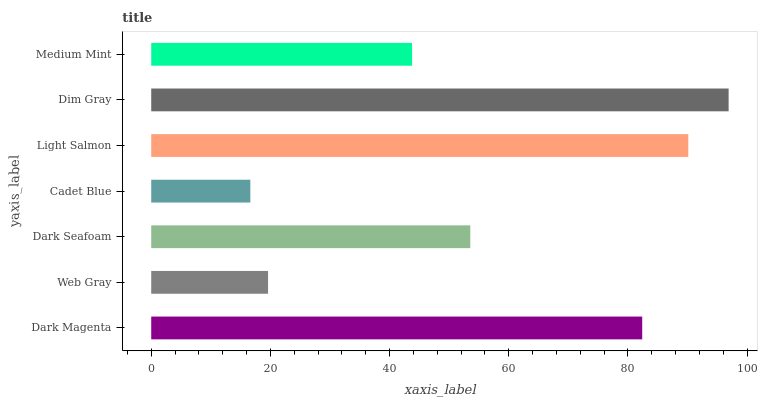Is Cadet Blue the minimum?
Answer yes or no. Yes. Is Dim Gray the maximum?
Answer yes or no. Yes. Is Web Gray the minimum?
Answer yes or no. No. Is Web Gray the maximum?
Answer yes or no. No. Is Dark Magenta greater than Web Gray?
Answer yes or no. Yes. Is Web Gray less than Dark Magenta?
Answer yes or no. Yes. Is Web Gray greater than Dark Magenta?
Answer yes or no. No. Is Dark Magenta less than Web Gray?
Answer yes or no. No. Is Dark Seafoam the high median?
Answer yes or no. Yes. Is Dark Seafoam the low median?
Answer yes or no. Yes. Is Dim Gray the high median?
Answer yes or no. No. Is Dark Magenta the low median?
Answer yes or no. No. 